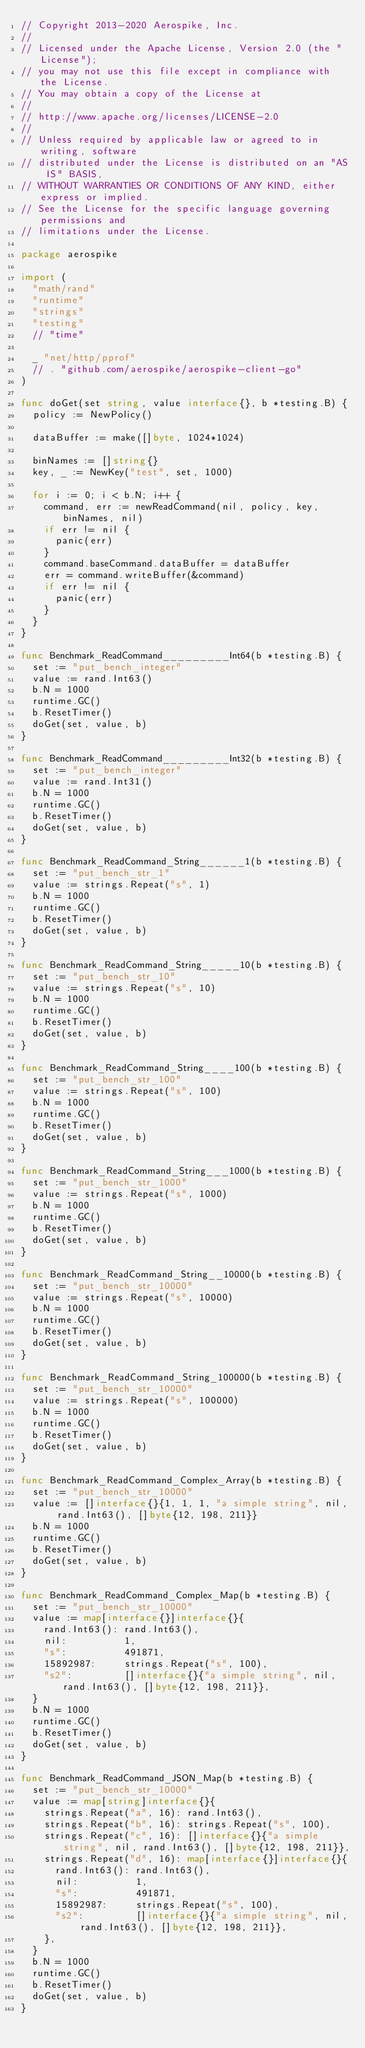Convert code to text. <code><loc_0><loc_0><loc_500><loc_500><_Go_>// Copyright 2013-2020 Aerospike, Inc.
//
// Licensed under the Apache License, Version 2.0 (the "License");
// you may not use this file except in compliance with the License.
// You may obtain a copy of the License at
//
// http://www.apache.org/licenses/LICENSE-2.0
//
// Unless required by applicable law or agreed to in writing, software
// distributed under the License is distributed on an "AS IS" BASIS,
// WITHOUT WARRANTIES OR CONDITIONS OF ANY KIND, either express or implied.
// See the License for the specific language governing permissions and
// limitations under the License.

package aerospike

import (
	"math/rand"
	"runtime"
	"strings"
	"testing"
	// "time"

	_ "net/http/pprof"
	// . "github.com/aerospike/aerospike-client-go"
)

func doGet(set string, value interface{}, b *testing.B) {
	policy := NewPolicy()

	dataBuffer := make([]byte, 1024*1024)

	binNames := []string{}
	key, _ := NewKey("test", set, 1000)

	for i := 0; i < b.N; i++ {
		command, err := newReadCommand(nil, policy, key, binNames, nil)
		if err != nil {
			panic(err)
		}
		command.baseCommand.dataBuffer = dataBuffer
		err = command.writeBuffer(&command)
		if err != nil {
			panic(err)
		}
	}
}

func Benchmark_ReadCommand_________Int64(b *testing.B) {
	set := "put_bench_integer"
	value := rand.Int63()
	b.N = 1000
	runtime.GC()
	b.ResetTimer()
	doGet(set, value, b)
}

func Benchmark_ReadCommand_________Int32(b *testing.B) {
	set := "put_bench_integer"
	value := rand.Int31()
	b.N = 1000
	runtime.GC()
	b.ResetTimer()
	doGet(set, value, b)
}

func Benchmark_ReadCommand_String______1(b *testing.B) {
	set := "put_bench_str_1"
	value := strings.Repeat("s", 1)
	b.N = 1000
	runtime.GC()
	b.ResetTimer()
	doGet(set, value, b)
}

func Benchmark_ReadCommand_String_____10(b *testing.B) {
	set := "put_bench_str_10"
	value := strings.Repeat("s", 10)
	b.N = 1000
	runtime.GC()
	b.ResetTimer()
	doGet(set, value, b)
}

func Benchmark_ReadCommand_String____100(b *testing.B) {
	set := "put_bench_str_100"
	value := strings.Repeat("s", 100)
	b.N = 1000
	runtime.GC()
	b.ResetTimer()
	doGet(set, value, b)
}

func Benchmark_ReadCommand_String___1000(b *testing.B) {
	set := "put_bench_str_1000"
	value := strings.Repeat("s", 1000)
	b.N = 1000
	runtime.GC()
	b.ResetTimer()
	doGet(set, value, b)
}

func Benchmark_ReadCommand_String__10000(b *testing.B) {
	set := "put_bench_str_10000"
	value := strings.Repeat("s", 10000)
	b.N = 1000
	runtime.GC()
	b.ResetTimer()
	doGet(set, value, b)
}

func Benchmark_ReadCommand_String_100000(b *testing.B) {
	set := "put_bench_str_10000"
	value := strings.Repeat("s", 100000)
	b.N = 1000
	runtime.GC()
	b.ResetTimer()
	doGet(set, value, b)
}

func Benchmark_ReadCommand_Complex_Array(b *testing.B) {
	set := "put_bench_str_10000"
	value := []interface{}{1, 1, 1, "a simple string", nil, rand.Int63(), []byte{12, 198, 211}}
	b.N = 1000
	runtime.GC()
	b.ResetTimer()
	doGet(set, value, b)
}

func Benchmark_ReadCommand_Complex_Map(b *testing.B) {
	set := "put_bench_str_10000"
	value := map[interface{}]interface{}{
		rand.Int63(): rand.Int63(),
		nil:          1,
		"s":          491871,
		15892987:     strings.Repeat("s", 100),
		"s2":         []interface{}{"a simple string", nil, rand.Int63(), []byte{12, 198, 211}},
	}
	b.N = 1000
	runtime.GC()
	b.ResetTimer()
	doGet(set, value, b)
}

func Benchmark_ReadCommand_JSON_Map(b *testing.B) {
	set := "put_bench_str_10000"
	value := map[string]interface{}{
		strings.Repeat("a", 16): rand.Int63(),
		strings.Repeat("b", 16): strings.Repeat("s", 100),
		strings.Repeat("c", 16): []interface{}{"a simple string", nil, rand.Int63(), []byte{12, 198, 211}},
		strings.Repeat("d", 16): map[interface{}]interface{}{
			rand.Int63(): rand.Int63(),
			nil:          1,
			"s":          491871,
			15892987:     strings.Repeat("s", 100),
			"s2":         []interface{}{"a simple string", nil, rand.Int63(), []byte{12, 198, 211}},
		},
	}
	b.N = 1000
	runtime.GC()
	b.ResetTimer()
	doGet(set, value, b)
}
</code> 